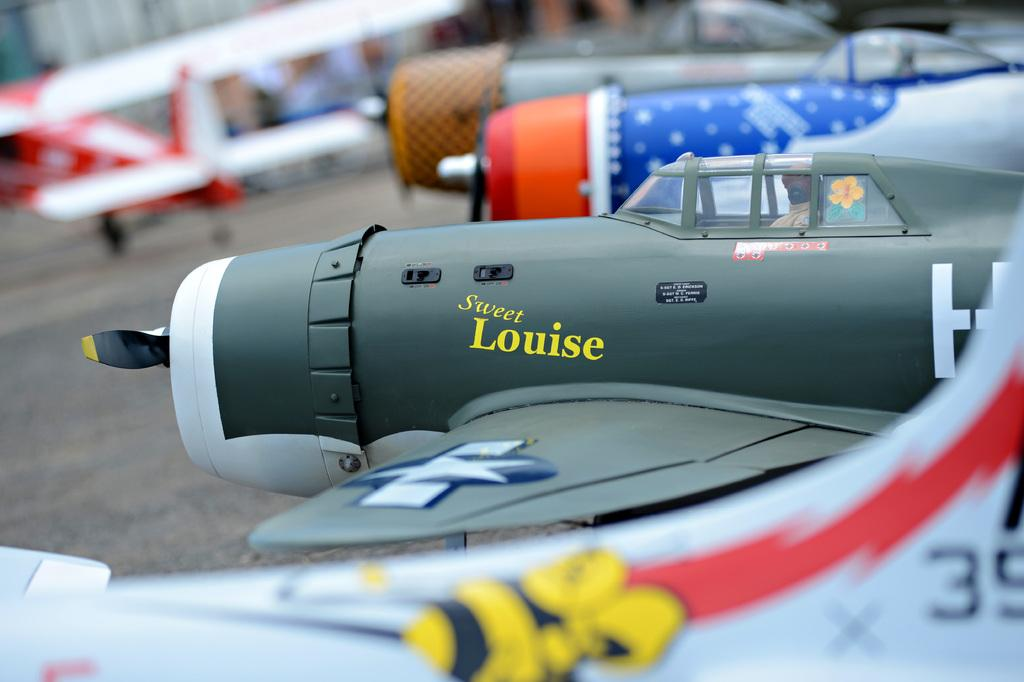<image>
Provide a brief description of the given image. A toy airplane with the name Sweet Louise written on the side 